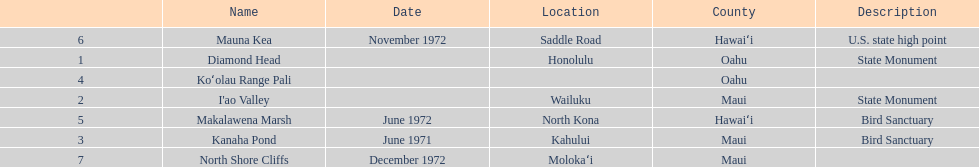Which national natural landmarks in hawaii are in oahu county? Diamond Head, Koʻolau Range Pali. Of these landmarks, which one is listed without a location? Koʻolau Range Pali. 